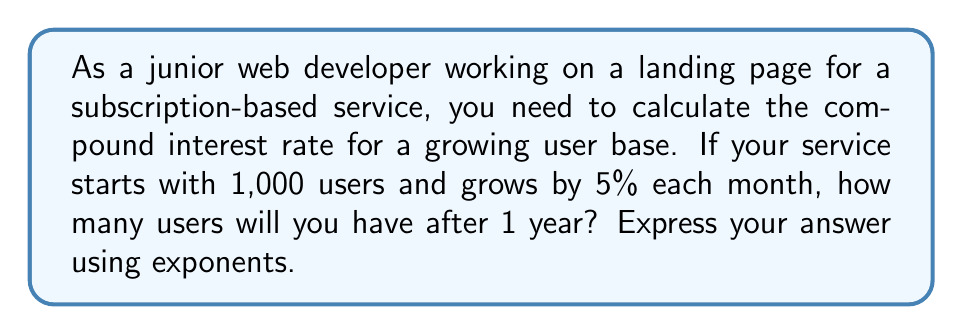Help me with this question. Let's approach this step-by-step:

1. We start with 1,000 users.
2. The growth rate is 5% (0.05) per month.
3. We want to calculate the number of users after 12 months (1 year).

The formula for compound interest is:

$$ A = P(1 + r)^n $$

Where:
- $A$ is the final amount
- $P$ is the initial principal balance (initial number of users)
- $r$ is the interest rate (in decimal form)
- $n$ is the number of times interest is compounded

In our case:
- $P = 1,000$
- $r = 0.05$ (5% expressed as a decimal)
- $n = 12$ (compounded monthly for one year)

Let's plug these values into our formula:

$$ A = 1,000(1 + 0.05)^{12} $$

This can be simplified to:

$$ A = 1,000(1.05)^{12} $$

To calculate this, we need to:
1. Calculate $(1.05)^{12}$
2. Multiply the result by 1,000

Using a calculator or programming function, we find:

$$ (1.05)^{12} \approx 1.7958 $$

Multiplying by 1,000:

$$ 1,000 * 1.7958 \approx 1,795.8 $$

Rounding to the nearest whole number (as we can't have fractional users), we get 1,796 users.
Answer: $$ 1,000(1.05)^{12} \approx 1,796 \text{ users} $$ 